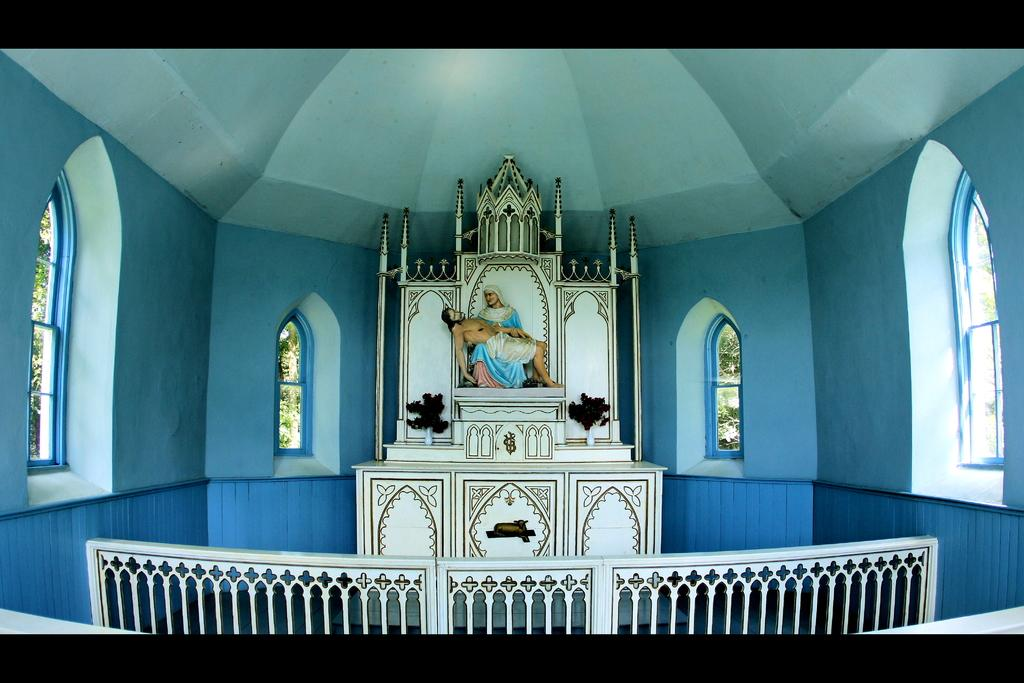What is the main subject of the image? There is a statue of Jesus in the image. Where is the image taken? The image is an inside view of a church. What can be seen through the windows in the image? The presence of windows suggests that there might be a view of the outside, but the specifics cannot be determined from the facts provided. What architectural feature is present in the image? There is a fence in the image. What color is the snail crawling on the statue of Jesus in the image? There is no snail present in the image, so it cannot be determined what color it might be. 